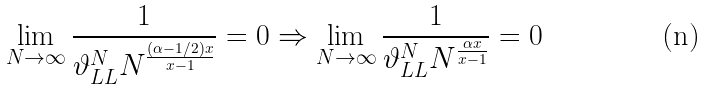Convert formula to latex. <formula><loc_0><loc_0><loc_500><loc_500>\lim _ { N \rightarrow \infty } \frac { 1 } { \vartheta _ { L L } ^ { N } N ^ { \frac { ( \alpha - 1 / 2 ) x } { x - 1 } } } = 0 \Rightarrow \lim _ { N \rightarrow \infty } \frac { 1 } { \vartheta _ { L L } ^ { N } N ^ { \frac { \alpha x } { x - 1 } } } = 0</formula> 